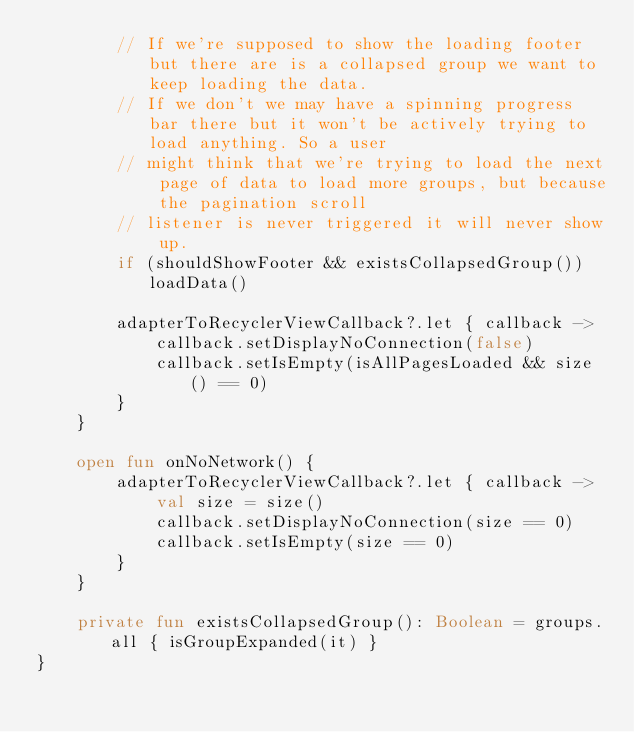<code> <loc_0><loc_0><loc_500><loc_500><_Kotlin_>        // If we're supposed to show the loading footer but there are is a collapsed group we want to keep loading the data.
        // If we don't we may have a spinning progress bar there but it won't be actively trying to load anything. So a user
        // might think that we're trying to load the next page of data to load more groups, but because the pagination scroll
        // listener is never triggered it will never show up.
        if (shouldShowFooter && existsCollapsedGroup()) loadData()

        adapterToRecyclerViewCallback?.let { callback ->
            callback.setDisplayNoConnection(false)
            callback.setIsEmpty(isAllPagesLoaded && size() == 0)
        }
    }

    open fun onNoNetwork() {
        adapterToRecyclerViewCallback?.let { callback ->
            val size = size()
            callback.setDisplayNoConnection(size == 0)
            callback.setIsEmpty(size == 0)
        }
    }

    private fun existsCollapsedGroup(): Boolean = groups.all { isGroupExpanded(it) }
}
</code> 